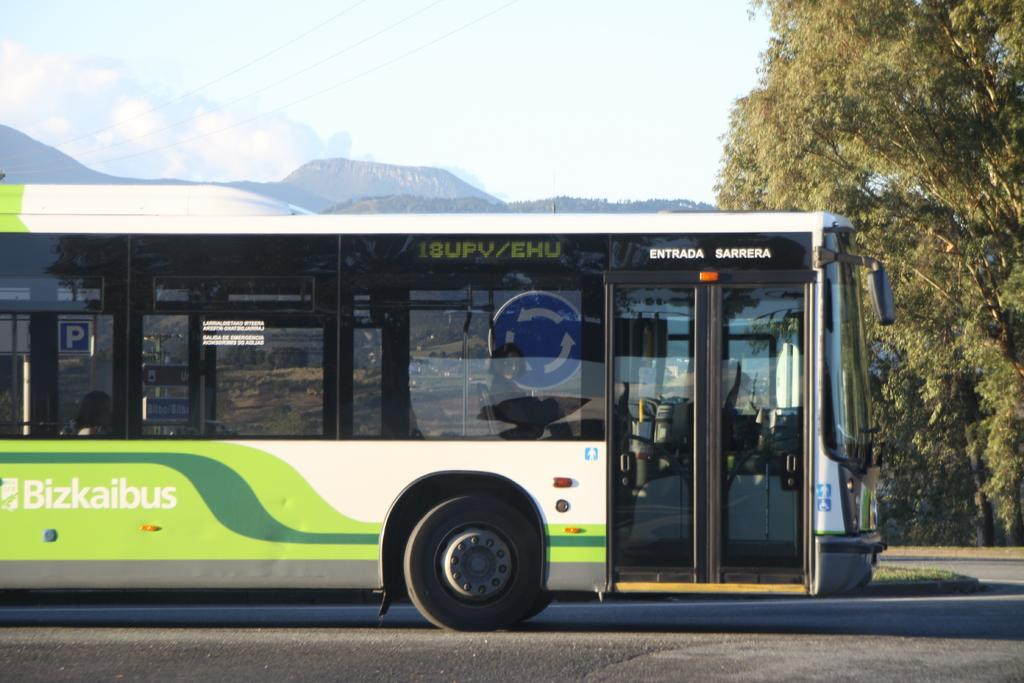Provide a one-sentence caption for the provided image. The Bizkaibus is used in a foreign country. 